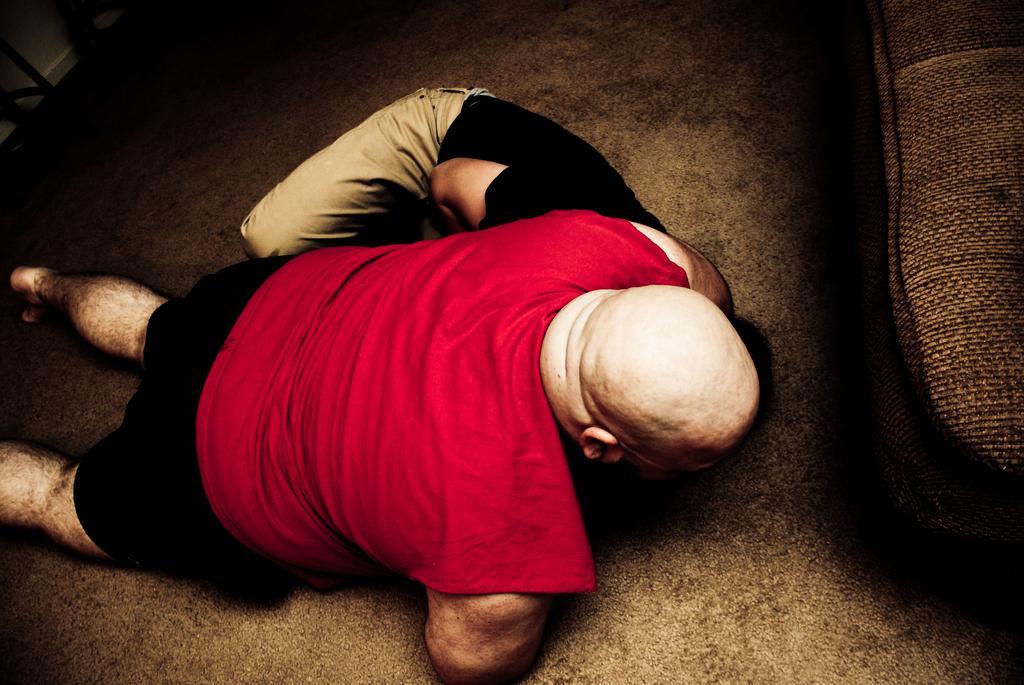Please provide a concise description of this image. This is an edited image. In the middle of the image there are two persons lying on the floor. It seems like they are fighting. On the right side there is a couch. 